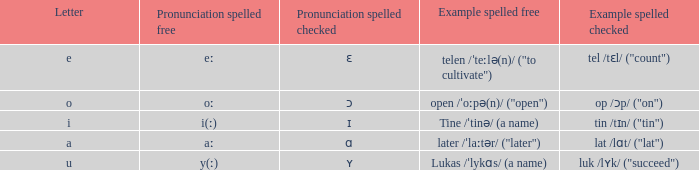What is Pronunciation Spelled Free, when Pronunciation Spelled Checked is "ɛ"? Eː. 